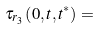<formula> <loc_0><loc_0><loc_500><loc_500>\tau _ { r _ { 3 } } \left ( 0 , { t } , { t ^ { * } } \right ) =</formula> 